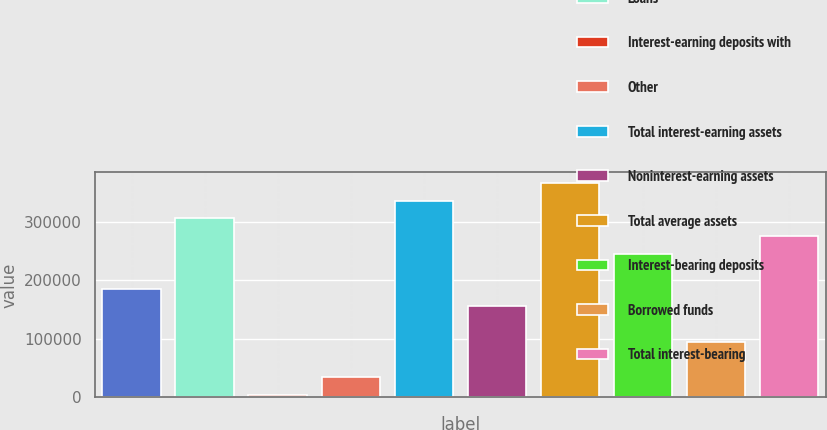Convert chart. <chart><loc_0><loc_0><loc_500><loc_500><bar_chart><fcel>Investment securities<fcel>Loans<fcel>Interest-earning deposits with<fcel>Other<fcel>Total interest-earning assets<fcel>Noninterest-earning assets<fcel>Total average assets<fcel>Interest-bearing deposits<fcel>Borrowed funds<fcel>Total interest-bearing<nl><fcel>185362<fcel>305664<fcel>4910<fcel>34985.4<fcel>335739<fcel>155287<fcel>365815<fcel>245513<fcel>95136.2<fcel>275589<nl></chart> 